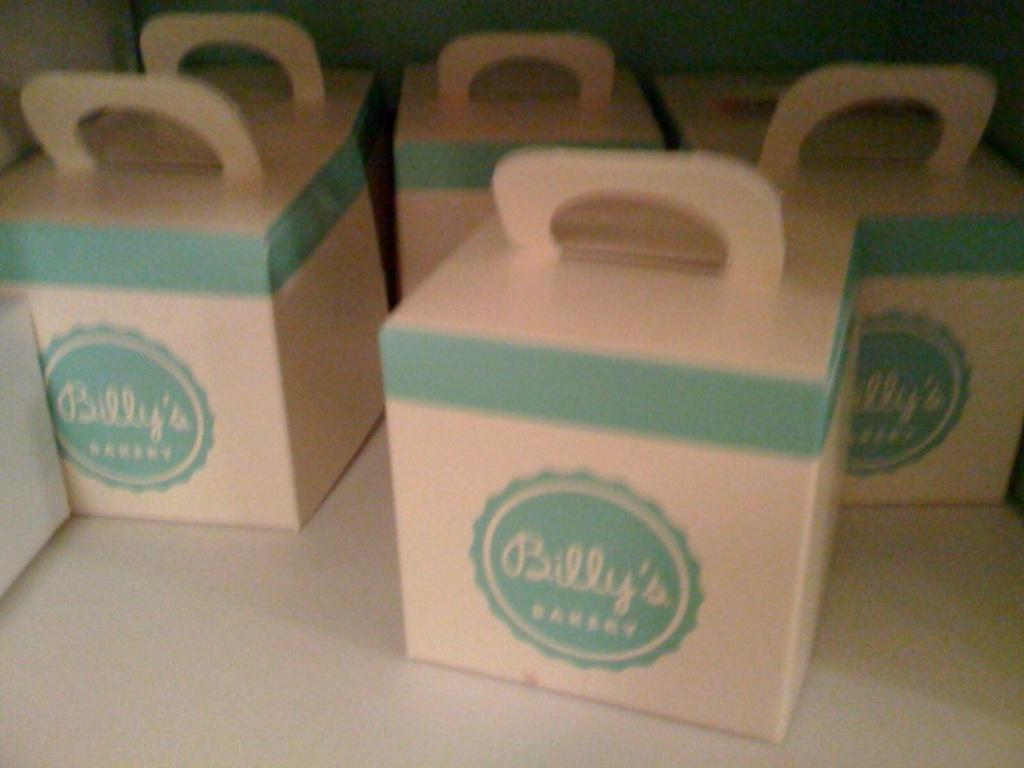<image>
Provide a brief description of the given image. Five cardboard boxes shown here fro Billy's Bakers. 